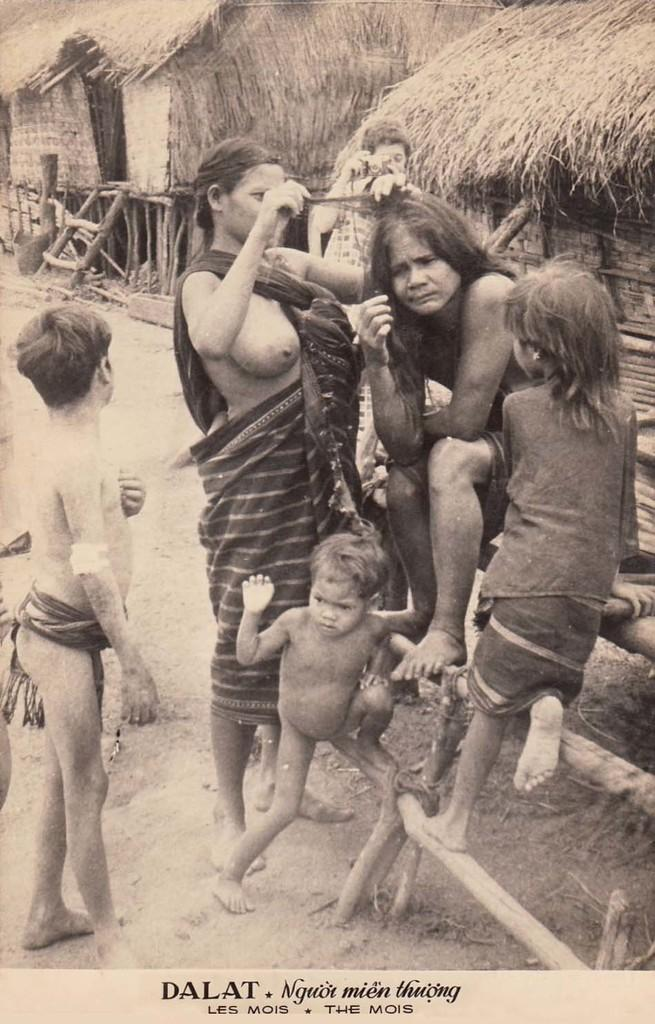What is the color scheme of the image? The image is black and white. Who is present in the image? There is a woman and children in the image. What can be seen in the background of the image? There are two huts in the background of the image. Is there any text in the image? Yes, there is text at the bottom of the image. How many buckets of dust can be seen in the image? There are no buckets or dust present in the image. What type of servant is attending to the woman in the image? There is no servant present in the image; it only features a woman and children. 